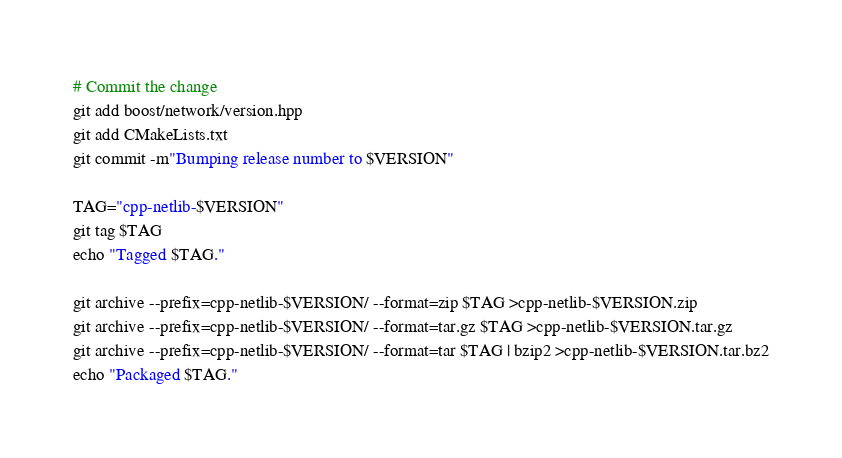Convert code to text. <code><loc_0><loc_0><loc_500><loc_500><_Bash_># Commit the change
git add boost/network/version.hpp
git add CMakeLists.txt
git commit -m"Bumping release number to $VERSION"

TAG="cpp-netlib-$VERSION"
git tag $TAG
echo "Tagged $TAG."

git archive --prefix=cpp-netlib-$VERSION/ --format=zip $TAG >cpp-netlib-$VERSION.zip
git archive --prefix=cpp-netlib-$VERSION/ --format=tar.gz $TAG >cpp-netlib-$VERSION.tar.gz
git archive --prefix=cpp-netlib-$VERSION/ --format=tar $TAG | bzip2 >cpp-netlib-$VERSION.tar.bz2
echo "Packaged $TAG."
</code> 